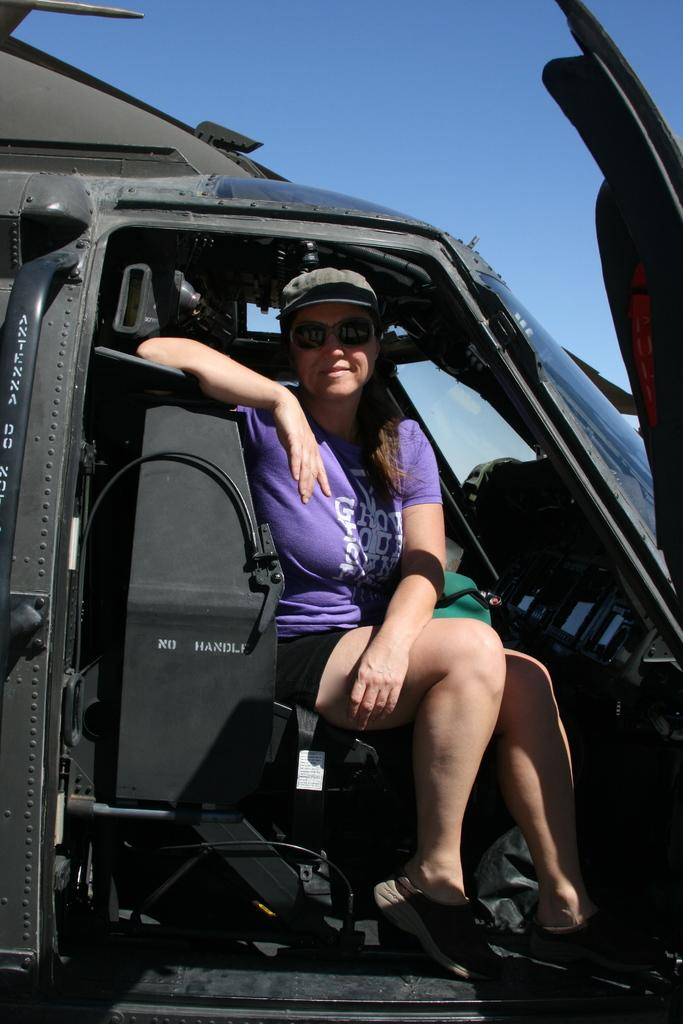What is the main subject of the image? The main subject of the image is a woman. What is the woman doing in the image? The woman is sitting in a vehicle. What is the woman's facial expression in the image? The woman is smiling. What is the color of the sky in the image? The sky is blue in color. What type of jewel is the woman wearing in the image? There is no reference to a jewel in the image, so it is not possible to determine what type of jewel the woman might be wearing. 